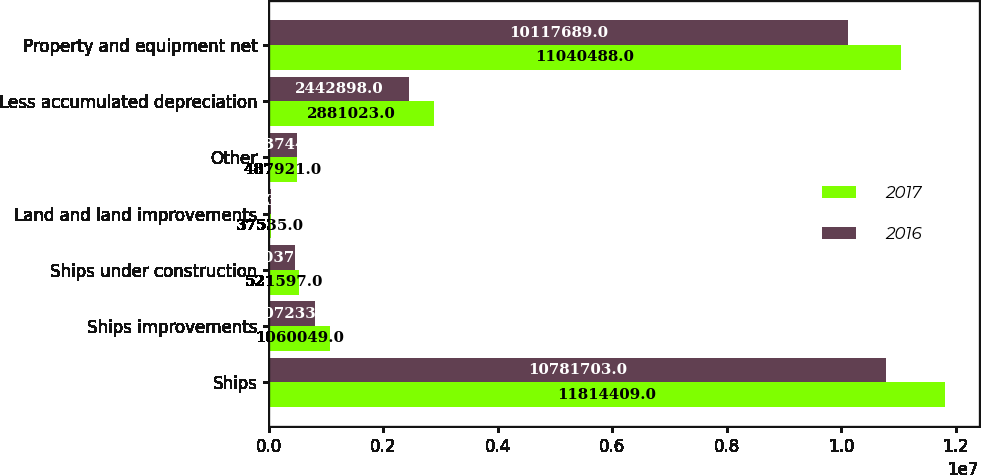Convert chart. <chart><loc_0><loc_0><loc_500><loc_500><stacked_bar_chart><ecel><fcel>Ships<fcel>Ships improvements<fcel>Ships under construction<fcel>Land and land improvements<fcel>Other<fcel>Less accumulated depreciation<fcel>Property and equipment net<nl><fcel>2017<fcel>1.18144e+07<fcel>1.06005e+06<fcel>521597<fcel>37535<fcel>487921<fcel>2.88102e+06<fcel>1.10405e+07<nl><fcel>2016<fcel>1.07817e+07<fcel>807233<fcel>450372<fcel>37535<fcel>483744<fcel>2.4429e+06<fcel>1.01177e+07<nl></chart> 